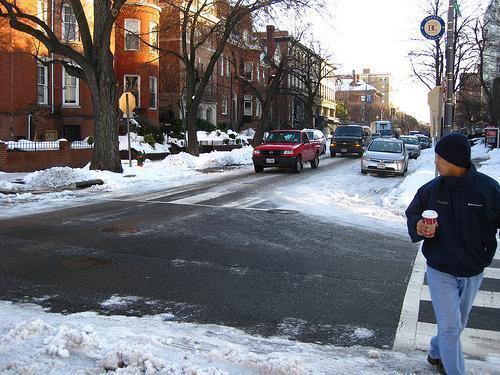How many people are walking?
Give a very brief answer. 1. 